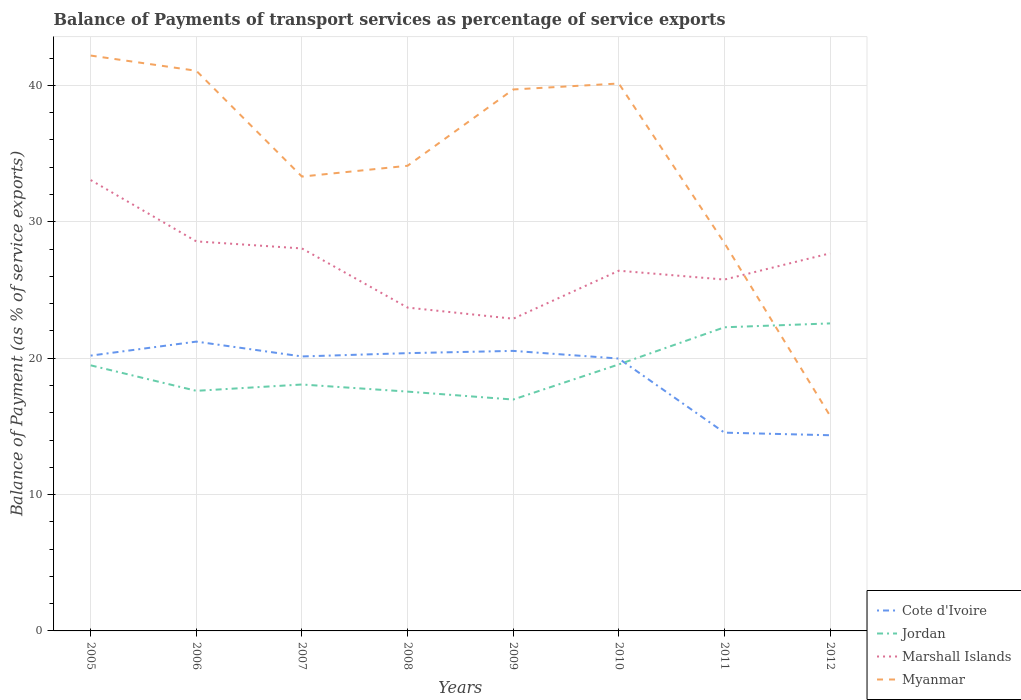How many different coloured lines are there?
Give a very brief answer. 4. Is the number of lines equal to the number of legend labels?
Give a very brief answer. Yes. Across all years, what is the maximum balance of payments of transport services in Marshall Islands?
Your answer should be compact. 22.89. What is the total balance of payments of transport services in Myanmar in the graph?
Your answer should be very brief. 1.12. What is the difference between the highest and the second highest balance of payments of transport services in Cote d'Ivoire?
Your response must be concise. 6.86. What is the difference between the highest and the lowest balance of payments of transport services in Myanmar?
Your answer should be compact. 4. Is the balance of payments of transport services in Jordan strictly greater than the balance of payments of transport services in Myanmar over the years?
Provide a short and direct response. No. How many lines are there?
Provide a succinct answer. 4. Are the values on the major ticks of Y-axis written in scientific E-notation?
Ensure brevity in your answer.  No. Does the graph contain grids?
Give a very brief answer. Yes. How many legend labels are there?
Provide a short and direct response. 4. What is the title of the graph?
Your answer should be compact. Balance of Payments of transport services as percentage of service exports. Does "Hungary" appear as one of the legend labels in the graph?
Make the answer very short. No. What is the label or title of the Y-axis?
Ensure brevity in your answer.  Balance of Payment (as % of service exports). What is the Balance of Payment (as % of service exports) of Cote d'Ivoire in 2005?
Ensure brevity in your answer.  20.19. What is the Balance of Payment (as % of service exports) of Jordan in 2005?
Provide a short and direct response. 19.47. What is the Balance of Payment (as % of service exports) of Marshall Islands in 2005?
Provide a short and direct response. 33.06. What is the Balance of Payment (as % of service exports) in Myanmar in 2005?
Offer a terse response. 42.19. What is the Balance of Payment (as % of service exports) of Cote d'Ivoire in 2006?
Provide a succinct answer. 21.21. What is the Balance of Payment (as % of service exports) in Jordan in 2006?
Provide a succinct answer. 17.61. What is the Balance of Payment (as % of service exports) of Marshall Islands in 2006?
Provide a succinct answer. 28.56. What is the Balance of Payment (as % of service exports) in Myanmar in 2006?
Provide a succinct answer. 41.08. What is the Balance of Payment (as % of service exports) of Cote d'Ivoire in 2007?
Offer a terse response. 20.13. What is the Balance of Payment (as % of service exports) in Jordan in 2007?
Your answer should be compact. 18.07. What is the Balance of Payment (as % of service exports) in Marshall Islands in 2007?
Your answer should be very brief. 28.05. What is the Balance of Payment (as % of service exports) in Myanmar in 2007?
Offer a very short reply. 33.32. What is the Balance of Payment (as % of service exports) of Cote d'Ivoire in 2008?
Provide a succinct answer. 20.37. What is the Balance of Payment (as % of service exports) of Jordan in 2008?
Your response must be concise. 17.55. What is the Balance of Payment (as % of service exports) of Marshall Islands in 2008?
Make the answer very short. 23.71. What is the Balance of Payment (as % of service exports) of Myanmar in 2008?
Your answer should be compact. 34.11. What is the Balance of Payment (as % of service exports) in Cote d'Ivoire in 2009?
Provide a succinct answer. 20.53. What is the Balance of Payment (as % of service exports) of Jordan in 2009?
Keep it short and to the point. 16.97. What is the Balance of Payment (as % of service exports) in Marshall Islands in 2009?
Your answer should be very brief. 22.89. What is the Balance of Payment (as % of service exports) of Myanmar in 2009?
Your answer should be very brief. 39.7. What is the Balance of Payment (as % of service exports) of Cote d'Ivoire in 2010?
Offer a very short reply. 19.97. What is the Balance of Payment (as % of service exports) in Jordan in 2010?
Provide a short and direct response. 19.54. What is the Balance of Payment (as % of service exports) of Marshall Islands in 2010?
Provide a short and direct response. 26.41. What is the Balance of Payment (as % of service exports) of Myanmar in 2010?
Ensure brevity in your answer.  40.14. What is the Balance of Payment (as % of service exports) in Cote d'Ivoire in 2011?
Provide a short and direct response. 14.54. What is the Balance of Payment (as % of service exports) in Jordan in 2011?
Provide a succinct answer. 22.27. What is the Balance of Payment (as % of service exports) in Marshall Islands in 2011?
Provide a short and direct response. 25.76. What is the Balance of Payment (as % of service exports) in Myanmar in 2011?
Your answer should be very brief. 28.44. What is the Balance of Payment (as % of service exports) in Cote d'Ivoire in 2012?
Your answer should be compact. 14.35. What is the Balance of Payment (as % of service exports) in Jordan in 2012?
Offer a very short reply. 22.55. What is the Balance of Payment (as % of service exports) in Marshall Islands in 2012?
Offer a very short reply. 27.69. What is the Balance of Payment (as % of service exports) of Myanmar in 2012?
Provide a short and direct response. 15.77. Across all years, what is the maximum Balance of Payment (as % of service exports) in Cote d'Ivoire?
Provide a short and direct response. 21.21. Across all years, what is the maximum Balance of Payment (as % of service exports) in Jordan?
Provide a short and direct response. 22.55. Across all years, what is the maximum Balance of Payment (as % of service exports) of Marshall Islands?
Your answer should be very brief. 33.06. Across all years, what is the maximum Balance of Payment (as % of service exports) in Myanmar?
Offer a very short reply. 42.19. Across all years, what is the minimum Balance of Payment (as % of service exports) of Cote d'Ivoire?
Your response must be concise. 14.35. Across all years, what is the minimum Balance of Payment (as % of service exports) of Jordan?
Offer a very short reply. 16.97. Across all years, what is the minimum Balance of Payment (as % of service exports) in Marshall Islands?
Ensure brevity in your answer.  22.89. Across all years, what is the minimum Balance of Payment (as % of service exports) of Myanmar?
Keep it short and to the point. 15.77. What is the total Balance of Payment (as % of service exports) of Cote d'Ivoire in the graph?
Offer a very short reply. 151.29. What is the total Balance of Payment (as % of service exports) in Jordan in the graph?
Provide a short and direct response. 154.03. What is the total Balance of Payment (as % of service exports) of Marshall Islands in the graph?
Provide a short and direct response. 216.14. What is the total Balance of Payment (as % of service exports) in Myanmar in the graph?
Your response must be concise. 274.75. What is the difference between the Balance of Payment (as % of service exports) in Cote d'Ivoire in 2005 and that in 2006?
Offer a very short reply. -1.03. What is the difference between the Balance of Payment (as % of service exports) in Jordan in 2005 and that in 2006?
Keep it short and to the point. 1.87. What is the difference between the Balance of Payment (as % of service exports) of Marshall Islands in 2005 and that in 2006?
Your response must be concise. 4.5. What is the difference between the Balance of Payment (as % of service exports) in Myanmar in 2005 and that in 2006?
Your answer should be very brief. 1.12. What is the difference between the Balance of Payment (as % of service exports) in Cote d'Ivoire in 2005 and that in 2007?
Keep it short and to the point. 0.06. What is the difference between the Balance of Payment (as % of service exports) in Jordan in 2005 and that in 2007?
Keep it short and to the point. 1.41. What is the difference between the Balance of Payment (as % of service exports) in Marshall Islands in 2005 and that in 2007?
Make the answer very short. 5.02. What is the difference between the Balance of Payment (as % of service exports) in Myanmar in 2005 and that in 2007?
Ensure brevity in your answer.  8.87. What is the difference between the Balance of Payment (as % of service exports) of Cote d'Ivoire in 2005 and that in 2008?
Provide a succinct answer. -0.18. What is the difference between the Balance of Payment (as % of service exports) in Jordan in 2005 and that in 2008?
Give a very brief answer. 1.93. What is the difference between the Balance of Payment (as % of service exports) of Marshall Islands in 2005 and that in 2008?
Your response must be concise. 9.35. What is the difference between the Balance of Payment (as % of service exports) of Myanmar in 2005 and that in 2008?
Your answer should be compact. 8.08. What is the difference between the Balance of Payment (as % of service exports) of Cote d'Ivoire in 2005 and that in 2009?
Offer a terse response. -0.35. What is the difference between the Balance of Payment (as % of service exports) of Jordan in 2005 and that in 2009?
Your answer should be very brief. 2.51. What is the difference between the Balance of Payment (as % of service exports) of Marshall Islands in 2005 and that in 2009?
Make the answer very short. 10.17. What is the difference between the Balance of Payment (as % of service exports) of Myanmar in 2005 and that in 2009?
Offer a terse response. 2.49. What is the difference between the Balance of Payment (as % of service exports) in Cote d'Ivoire in 2005 and that in 2010?
Offer a very short reply. 0.22. What is the difference between the Balance of Payment (as % of service exports) in Jordan in 2005 and that in 2010?
Offer a terse response. -0.07. What is the difference between the Balance of Payment (as % of service exports) of Marshall Islands in 2005 and that in 2010?
Offer a very short reply. 6.65. What is the difference between the Balance of Payment (as % of service exports) of Myanmar in 2005 and that in 2010?
Your response must be concise. 2.05. What is the difference between the Balance of Payment (as % of service exports) of Cote d'Ivoire in 2005 and that in 2011?
Offer a very short reply. 5.65. What is the difference between the Balance of Payment (as % of service exports) of Jordan in 2005 and that in 2011?
Make the answer very short. -2.79. What is the difference between the Balance of Payment (as % of service exports) in Marshall Islands in 2005 and that in 2011?
Provide a succinct answer. 7.3. What is the difference between the Balance of Payment (as % of service exports) in Myanmar in 2005 and that in 2011?
Your answer should be very brief. 13.75. What is the difference between the Balance of Payment (as % of service exports) of Cote d'Ivoire in 2005 and that in 2012?
Provide a short and direct response. 5.84. What is the difference between the Balance of Payment (as % of service exports) in Jordan in 2005 and that in 2012?
Offer a terse response. -3.07. What is the difference between the Balance of Payment (as % of service exports) in Marshall Islands in 2005 and that in 2012?
Your response must be concise. 5.37. What is the difference between the Balance of Payment (as % of service exports) of Myanmar in 2005 and that in 2012?
Your response must be concise. 26.42. What is the difference between the Balance of Payment (as % of service exports) in Cote d'Ivoire in 2006 and that in 2007?
Your answer should be compact. 1.09. What is the difference between the Balance of Payment (as % of service exports) in Jordan in 2006 and that in 2007?
Give a very brief answer. -0.46. What is the difference between the Balance of Payment (as % of service exports) in Marshall Islands in 2006 and that in 2007?
Ensure brevity in your answer.  0.52. What is the difference between the Balance of Payment (as % of service exports) in Myanmar in 2006 and that in 2007?
Your answer should be compact. 7.76. What is the difference between the Balance of Payment (as % of service exports) of Cote d'Ivoire in 2006 and that in 2008?
Offer a terse response. 0.85. What is the difference between the Balance of Payment (as % of service exports) of Jordan in 2006 and that in 2008?
Make the answer very short. 0.06. What is the difference between the Balance of Payment (as % of service exports) in Marshall Islands in 2006 and that in 2008?
Your answer should be very brief. 4.85. What is the difference between the Balance of Payment (as % of service exports) of Myanmar in 2006 and that in 2008?
Your response must be concise. 6.97. What is the difference between the Balance of Payment (as % of service exports) in Cote d'Ivoire in 2006 and that in 2009?
Provide a short and direct response. 0.68. What is the difference between the Balance of Payment (as % of service exports) of Jordan in 2006 and that in 2009?
Your answer should be very brief. 0.64. What is the difference between the Balance of Payment (as % of service exports) of Marshall Islands in 2006 and that in 2009?
Keep it short and to the point. 5.67. What is the difference between the Balance of Payment (as % of service exports) of Myanmar in 2006 and that in 2009?
Provide a succinct answer. 1.37. What is the difference between the Balance of Payment (as % of service exports) of Cote d'Ivoire in 2006 and that in 2010?
Provide a succinct answer. 1.24. What is the difference between the Balance of Payment (as % of service exports) of Jordan in 2006 and that in 2010?
Offer a terse response. -1.94. What is the difference between the Balance of Payment (as % of service exports) of Marshall Islands in 2006 and that in 2010?
Keep it short and to the point. 2.15. What is the difference between the Balance of Payment (as % of service exports) in Myanmar in 2006 and that in 2010?
Provide a succinct answer. 0.93. What is the difference between the Balance of Payment (as % of service exports) in Cote d'Ivoire in 2006 and that in 2011?
Offer a very short reply. 6.68. What is the difference between the Balance of Payment (as % of service exports) in Jordan in 2006 and that in 2011?
Keep it short and to the point. -4.66. What is the difference between the Balance of Payment (as % of service exports) in Marshall Islands in 2006 and that in 2011?
Provide a succinct answer. 2.8. What is the difference between the Balance of Payment (as % of service exports) in Myanmar in 2006 and that in 2011?
Keep it short and to the point. 12.63. What is the difference between the Balance of Payment (as % of service exports) of Cote d'Ivoire in 2006 and that in 2012?
Provide a succinct answer. 6.87. What is the difference between the Balance of Payment (as % of service exports) of Jordan in 2006 and that in 2012?
Ensure brevity in your answer.  -4.94. What is the difference between the Balance of Payment (as % of service exports) of Marshall Islands in 2006 and that in 2012?
Offer a very short reply. 0.88. What is the difference between the Balance of Payment (as % of service exports) of Myanmar in 2006 and that in 2012?
Your answer should be very brief. 25.3. What is the difference between the Balance of Payment (as % of service exports) in Cote d'Ivoire in 2007 and that in 2008?
Ensure brevity in your answer.  -0.24. What is the difference between the Balance of Payment (as % of service exports) of Jordan in 2007 and that in 2008?
Make the answer very short. 0.52. What is the difference between the Balance of Payment (as % of service exports) of Marshall Islands in 2007 and that in 2008?
Offer a very short reply. 4.34. What is the difference between the Balance of Payment (as % of service exports) of Myanmar in 2007 and that in 2008?
Give a very brief answer. -0.79. What is the difference between the Balance of Payment (as % of service exports) in Cote d'Ivoire in 2007 and that in 2009?
Provide a short and direct response. -0.41. What is the difference between the Balance of Payment (as % of service exports) of Jordan in 2007 and that in 2009?
Keep it short and to the point. 1.1. What is the difference between the Balance of Payment (as % of service exports) in Marshall Islands in 2007 and that in 2009?
Provide a short and direct response. 5.15. What is the difference between the Balance of Payment (as % of service exports) of Myanmar in 2007 and that in 2009?
Your answer should be very brief. -6.39. What is the difference between the Balance of Payment (as % of service exports) in Cote d'Ivoire in 2007 and that in 2010?
Provide a short and direct response. 0.15. What is the difference between the Balance of Payment (as % of service exports) of Jordan in 2007 and that in 2010?
Your answer should be compact. -1.47. What is the difference between the Balance of Payment (as % of service exports) in Marshall Islands in 2007 and that in 2010?
Your answer should be compact. 1.63. What is the difference between the Balance of Payment (as % of service exports) of Myanmar in 2007 and that in 2010?
Your answer should be very brief. -6.82. What is the difference between the Balance of Payment (as % of service exports) of Cote d'Ivoire in 2007 and that in 2011?
Ensure brevity in your answer.  5.59. What is the difference between the Balance of Payment (as % of service exports) in Jordan in 2007 and that in 2011?
Offer a very short reply. -4.2. What is the difference between the Balance of Payment (as % of service exports) of Marshall Islands in 2007 and that in 2011?
Provide a short and direct response. 2.28. What is the difference between the Balance of Payment (as % of service exports) in Myanmar in 2007 and that in 2011?
Ensure brevity in your answer.  4.87. What is the difference between the Balance of Payment (as % of service exports) in Cote d'Ivoire in 2007 and that in 2012?
Your answer should be very brief. 5.78. What is the difference between the Balance of Payment (as % of service exports) of Jordan in 2007 and that in 2012?
Offer a very short reply. -4.48. What is the difference between the Balance of Payment (as % of service exports) of Marshall Islands in 2007 and that in 2012?
Offer a terse response. 0.36. What is the difference between the Balance of Payment (as % of service exports) of Myanmar in 2007 and that in 2012?
Your answer should be compact. 17.54. What is the difference between the Balance of Payment (as % of service exports) in Cote d'Ivoire in 2008 and that in 2009?
Offer a terse response. -0.17. What is the difference between the Balance of Payment (as % of service exports) of Jordan in 2008 and that in 2009?
Make the answer very short. 0.58. What is the difference between the Balance of Payment (as % of service exports) of Marshall Islands in 2008 and that in 2009?
Offer a very short reply. 0.82. What is the difference between the Balance of Payment (as % of service exports) in Myanmar in 2008 and that in 2009?
Keep it short and to the point. -5.59. What is the difference between the Balance of Payment (as % of service exports) of Cote d'Ivoire in 2008 and that in 2010?
Offer a terse response. 0.4. What is the difference between the Balance of Payment (as % of service exports) in Jordan in 2008 and that in 2010?
Ensure brevity in your answer.  -1.99. What is the difference between the Balance of Payment (as % of service exports) of Marshall Islands in 2008 and that in 2010?
Your response must be concise. -2.7. What is the difference between the Balance of Payment (as % of service exports) in Myanmar in 2008 and that in 2010?
Make the answer very short. -6.03. What is the difference between the Balance of Payment (as % of service exports) in Cote d'Ivoire in 2008 and that in 2011?
Your answer should be very brief. 5.83. What is the difference between the Balance of Payment (as % of service exports) of Jordan in 2008 and that in 2011?
Keep it short and to the point. -4.72. What is the difference between the Balance of Payment (as % of service exports) of Marshall Islands in 2008 and that in 2011?
Provide a short and direct response. -2.05. What is the difference between the Balance of Payment (as % of service exports) of Myanmar in 2008 and that in 2011?
Give a very brief answer. 5.67. What is the difference between the Balance of Payment (as % of service exports) of Cote d'Ivoire in 2008 and that in 2012?
Your answer should be compact. 6.02. What is the difference between the Balance of Payment (as % of service exports) of Jordan in 2008 and that in 2012?
Offer a terse response. -5. What is the difference between the Balance of Payment (as % of service exports) of Marshall Islands in 2008 and that in 2012?
Your answer should be compact. -3.98. What is the difference between the Balance of Payment (as % of service exports) in Myanmar in 2008 and that in 2012?
Provide a succinct answer. 18.34. What is the difference between the Balance of Payment (as % of service exports) in Cote d'Ivoire in 2009 and that in 2010?
Your answer should be compact. 0.56. What is the difference between the Balance of Payment (as % of service exports) of Jordan in 2009 and that in 2010?
Give a very brief answer. -2.58. What is the difference between the Balance of Payment (as % of service exports) of Marshall Islands in 2009 and that in 2010?
Give a very brief answer. -3.52. What is the difference between the Balance of Payment (as % of service exports) in Myanmar in 2009 and that in 2010?
Give a very brief answer. -0.44. What is the difference between the Balance of Payment (as % of service exports) of Cote d'Ivoire in 2009 and that in 2011?
Offer a terse response. 6. What is the difference between the Balance of Payment (as % of service exports) in Jordan in 2009 and that in 2011?
Give a very brief answer. -5.3. What is the difference between the Balance of Payment (as % of service exports) in Marshall Islands in 2009 and that in 2011?
Ensure brevity in your answer.  -2.87. What is the difference between the Balance of Payment (as % of service exports) of Myanmar in 2009 and that in 2011?
Offer a very short reply. 11.26. What is the difference between the Balance of Payment (as % of service exports) in Cote d'Ivoire in 2009 and that in 2012?
Provide a succinct answer. 6.18. What is the difference between the Balance of Payment (as % of service exports) of Jordan in 2009 and that in 2012?
Your response must be concise. -5.58. What is the difference between the Balance of Payment (as % of service exports) of Marshall Islands in 2009 and that in 2012?
Give a very brief answer. -4.8. What is the difference between the Balance of Payment (as % of service exports) in Myanmar in 2009 and that in 2012?
Offer a terse response. 23.93. What is the difference between the Balance of Payment (as % of service exports) of Cote d'Ivoire in 2010 and that in 2011?
Provide a succinct answer. 5.43. What is the difference between the Balance of Payment (as % of service exports) of Jordan in 2010 and that in 2011?
Keep it short and to the point. -2.72. What is the difference between the Balance of Payment (as % of service exports) of Marshall Islands in 2010 and that in 2011?
Provide a short and direct response. 0.65. What is the difference between the Balance of Payment (as % of service exports) of Myanmar in 2010 and that in 2011?
Ensure brevity in your answer.  11.7. What is the difference between the Balance of Payment (as % of service exports) in Cote d'Ivoire in 2010 and that in 2012?
Your answer should be compact. 5.62. What is the difference between the Balance of Payment (as % of service exports) of Jordan in 2010 and that in 2012?
Ensure brevity in your answer.  -3.01. What is the difference between the Balance of Payment (as % of service exports) of Marshall Islands in 2010 and that in 2012?
Offer a very short reply. -1.27. What is the difference between the Balance of Payment (as % of service exports) in Myanmar in 2010 and that in 2012?
Your response must be concise. 24.37. What is the difference between the Balance of Payment (as % of service exports) in Cote d'Ivoire in 2011 and that in 2012?
Give a very brief answer. 0.19. What is the difference between the Balance of Payment (as % of service exports) in Jordan in 2011 and that in 2012?
Your answer should be compact. -0.28. What is the difference between the Balance of Payment (as % of service exports) of Marshall Islands in 2011 and that in 2012?
Give a very brief answer. -1.92. What is the difference between the Balance of Payment (as % of service exports) of Myanmar in 2011 and that in 2012?
Your answer should be very brief. 12.67. What is the difference between the Balance of Payment (as % of service exports) of Cote d'Ivoire in 2005 and the Balance of Payment (as % of service exports) of Jordan in 2006?
Keep it short and to the point. 2.58. What is the difference between the Balance of Payment (as % of service exports) of Cote d'Ivoire in 2005 and the Balance of Payment (as % of service exports) of Marshall Islands in 2006?
Your response must be concise. -8.38. What is the difference between the Balance of Payment (as % of service exports) in Cote d'Ivoire in 2005 and the Balance of Payment (as % of service exports) in Myanmar in 2006?
Offer a very short reply. -20.89. What is the difference between the Balance of Payment (as % of service exports) in Jordan in 2005 and the Balance of Payment (as % of service exports) in Marshall Islands in 2006?
Provide a succinct answer. -9.09. What is the difference between the Balance of Payment (as % of service exports) of Jordan in 2005 and the Balance of Payment (as % of service exports) of Myanmar in 2006?
Your response must be concise. -21.6. What is the difference between the Balance of Payment (as % of service exports) of Marshall Islands in 2005 and the Balance of Payment (as % of service exports) of Myanmar in 2006?
Provide a succinct answer. -8.01. What is the difference between the Balance of Payment (as % of service exports) of Cote d'Ivoire in 2005 and the Balance of Payment (as % of service exports) of Jordan in 2007?
Ensure brevity in your answer.  2.12. What is the difference between the Balance of Payment (as % of service exports) of Cote d'Ivoire in 2005 and the Balance of Payment (as % of service exports) of Marshall Islands in 2007?
Offer a very short reply. -7.86. What is the difference between the Balance of Payment (as % of service exports) of Cote d'Ivoire in 2005 and the Balance of Payment (as % of service exports) of Myanmar in 2007?
Your answer should be very brief. -13.13. What is the difference between the Balance of Payment (as % of service exports) of Jordan in 2005 and the Balance of Payment (as % of service exports) of Marshall Islands in 2007?
Your response must be concise. -8.57. What is the difference between the Balance of Payment (as % of service exports) of Jordan in 2005 and the Balance of Payment (as % of service exports) of Myanmar in 2007?
Offer a terse response. -13.84. What is the difference between the Balance of Payment (as % of service exports) in Marshall Islands in 2005 and the Balance of Payment (as % of service exports) in Myanmar in 2007?
Provide a succinct answer. -0.26. What is the difference between the Balance of Payment (as % of service exports) in Cote d'Ivoire in 2005 and the Balance of Payment (as % of service exports) in Jordan in 2008?
Give a very brief answer. 2.64. What is the difference between the Balance of Payment (as % of service exports) of Cote d'Ivoire in 2005 and the Balance of Payment (as % of service exports) of Marshall Islands in 2008?
Your response must be concise. -3.52. What is the difference between the Balance of Payment (as % of service exports) in Cote d'Ivoire in 2005 and the Balance of Payment (as % of service exports) in Myanmar in 2008?
Offer a terse response. -13.92. What is the difference between the Balance of Payment (as % of service exports) of Jordan in 2005 and the Balance of Payment (as % of service exports) of Marshall Islands in 2008?
Offer a very short reply. -4.24. What is the difference between the Balance of Payment (as % of service exports) in Jordan in 2005 and the Balance of Payment (as % of service exports) in Myanmar in 2008?
Provide a succinct answer. -14.63. What is the difference between the Balance of Payment (as % of service exports) of Marshall Islands in 2005 and the Balance of Payment (as % of service exports) of Myanmar in 2008?
Your answer should be compact. -1.05. What is the difference between the Balance of Payment (as % of service exports) of Cote d'Ivoire in 2005 and the Balance of Payment (as % of service exports) of Jordan in 2009?
Your answer should be compact. 3.22. What is the difference between the Balance of Payment (as % of service exports) in Cote d'Ivoire in 2005 and the Balance of Payment (as % of service exports) in Marshall Islands in 2009?
Offer a very short reply. -2.7. What is the difference between the Balance of Payment (as % of service exports) in Cote d'Ivoire in 2005 and the Balance of Payment (as % of service exports) in Myanmar in 2009?
Give a very brief answer. -19.52. What is the difference between the Balance of Payment (as % of service exports) of Jordan in 2005 and the Balance of Payment (as % of service exports) of Marshall Islands in 2009?
Keep it short and to the point. -3.42. What is the difference between the Balance of Payment (as % of service exports) in Jordan in 2005 and the Balance of Payment (as % of service exports) in Myanmar in 2009?
Make the answer very short. -20.23. What is the difference between the Balance of Payment (as % of service exports) of Marshall Islands in 2005 and the Balance of Payment (as % of service exports) of Myanmar in 2009?
Keep it short and to the point. -6.64. What is the difference between the Balance of Payment (as % of service exports) of Cote d'Ivoire in 2005 and the Balance of Payment (as % of service exports) of Jordan in 2010?
Ensure brevity in your answer.  0.64. What is the difference between the Balance of Payment (as % of service exports) of Cote d'Ivoire in 2005 and the Balance of Payment (as % of service exports) of Marshall Islands in 2010?
Your answer should be very brief. -6.23. What is the difference between the Balance of Payment (as % of service exports) in Cote d'Ivoire in 2005 and the Balance of Payment (as % of service exports) in Myanmar in 2010?
Ensure brevity in your answer.  -19.95. What is the difference between the Balance of Payment (as % of service exports) of Jordan in 2005 and the Balance of Payment (as % of service exports) of Marshall Islands in 2010?
Offer a very short reply. -6.94. What is the difference between the Balance of Payment (as % of service exports) of Jordan in 2005 and the Balance of Payment (as % of service exports) of Myanmar in 2010?
Provide a succinct answer. -20.67. What is the difference between the Balance of Payment (as % of service exports) in Marshall Islands in 2005 and the Balance of Payment (as % of service exports) in Myanmar in 2010?
Your answer should be very brief. -7.08. What is the difference between the Balance of Payment (as % of service exports) of Cote d'Ivoire in 2005 and the Balance of Payment (as % of service exports) of Jordan in 2011?
Give a very brief answer. -2.08. What is the difference between the Balance of Payment (as % of service exports) in Cote d'Ivoire in 2005 and the Balance of Payment (as % of service exports) in Marshall Islands in 2011?
Ensure brevity in your answer.  -5.58. What is the difference between the Balance of Payment (as % of service exports) in Cote d'Ivoire in 2005 and the Balance of Payment (as % of service exports) in Myanmar in 2011?
Provide a short and direct response. -8.26. What is the difference between the Balance of Payment (as % of service exports) in Jordan in 2005 and the Balance of Payment (as % of service exports) in Marshall Islands in 2011?
Make the answer very short. -6.29. What is the difference between the Balance of Payment (as % of service exports) in Jordan in 2005 and the Balance of Payment (as % of service exports) in Myanmar in 2011?
Your answer should be compact. -8.97. What is the difference between the Balance of Payment (as % of service exports) of Marshall Islands in 2005 and the Balance of Payment (as % of service exports) of Myanmar in 2011?
Offer a terse response. 4.62. What is the difference between the Balance of Payment (as % of service exports) of Cote d'Ivoire in 2005 and the Balance of Payment (as % of service exports) of Jordan in 2012?
Ensure brevity in your answer.  -2.36. What is the difference between the Balance of Payment (as % of service exports) of Cote d'Ivoire in 2005 and the Balance of Payment (as % of service exports) of Marshall Islands in 2012?
Make the answer very short. -7.5. What is the difference between the Balance of Payment (as % of service exports) in Cote d'Ivoire in 2005 and the Balance of Payment (as % of service exports) in Myanmar in 2012?
Keep it short and to the point. 4.41. What is the difference between the Balance of Payment (as % of service exports) in Jordan in 2005 and the Balance of Payment (as % of service exports) in Marshall Islands in 2012?
Give a very brief answer. -8.21. What is the difference between the Balance of Payment (as % of service exports) of Jordan in 2005 and the Balance of Payment (as % of service exports) of Myanmar in 2012?
Give a very brief answer. 3.7. What is the difference between the Balance of Payment (as % of service exports) in Marshall Islands in 2005 and the Balance of Payment (as % of service exports) in Myanmar in 2012?
Keep it short and to the point. 17.29. What is the difference between the Balance of Payment (as % of service exports) in Cote d'Ivoire in 2006 and the Balance of Payment (as % of service exports) in Jordan in 2007?
Make the answer very short. 3.15. What is the difference between the Balance of Payment (as % of service exports) of Cote d'Ivoire in 2006 and the Balance of Payment (as % of service exports) of Marshall Islands in 2007?
Ensure brevity in your answer.  -6.83. What is the difference between the Balance of Payment (as % of service exports) of Cote d'Ivoire in 2006 and the Balance of Payment (as % of service exports) of Myanmar in 2007?
Ensure brevity in your answer.  -12.1. What is the difference between the Balance of Payment (as % of service exports) in Jordan in 2006 and the Balance of Payment (as % of service exports) in Marshall Islands in 2007?
Offer a very short reply. -10.44. What is the difference between the Balance of Payment (as % of service exports) in Jordan in 2006 and the Balance of Payment (as % of service exports) in Myanmar in 2007?
Your answer should be very brief. -15.71. What is the difference between the Balance of Payment (as % of service exports) of Marshall Islands in 2006 and the Balance of Payment (as % of service exports) of Myanmar in 2007?
Make the answer very short. -4.75. What is the difference between the Balance of Payment (as % of service exports) of Cote d'Ivoire in 2006 and the Balance of Payment (as % of service exports) of Jordan in 2008?
Ensure brevity in your answer.  3.67. What is the difference between the Balance of Payment (as % of service exports) of Cote d'Ivoire in 2006 and the Balance of Payment (as % of service exports) of Marshall Islands in 2008?
Offer a terse response. -2.5. What is the difference between the Balance of Payment (as % of service exports) of Cote d'Ivoire in 2006 and the Balance of Payment (as % of service exports) of Myanmar in 2008?
Offer a very short reply. -12.89. What is the difference between the Balance of Payment (as % of service exports) in Jordan in 2006 and the Balance of Payment (as % of service exports) in Marshall Islands in 2008?
Make the answer very short. -6.1. What is the difference between the Balance of Payment (as % of service exports) of Jordan in 2006 and the Balance of Payment (as % of service exports) of Myanmar in 2008?
Ensure brevity in your answer.  -16.5. What is the difference between the Balance of Payment (as % of service exports) in Marshall Islands in 2006 and the Balance of Payment (as % of service exports) in Myanmar in 2008?
Offer a terse response. -5.54. What is the difference between the Balance of Payment (as % of service exports) in Cote d'Ivoire in 2006 and the Balance of Payment (as % of service exports) in Jordan in 2009?
Give a very brief answer. 4.25. What is the difference between the Balance of Payment (as % of service exports) in Cote d'Ivoire in 2006 and the Balance of Payment (as % of service exports) in Marshall Islands in 2009?
Provide a succinct answer. -1.68. What is the difference between the Balance of Payment (as % of service exports) of Cote d'Ivoire in 2006 and the Balance of Payment (as % of service exports) of Myanmar in 2009?
Your answer should be compact. -18.49. What is the difference between the Balance of Payment (as % of service exports) of Jordan in 2006 and the Balance of Payment (as % of service exports) of Marshall Islands in 2009?
Offer a terse response. -5.29. What is the difference between the Balance of Payment (as % of service exports) in Jordan in 2006 and the Balance of Payment (as % of service exports) in Myanmar in 2009?
Ensure brevity in your answer.  -22.1. What is the difference between the Balance of Payment (as % of service exports) of Marshall Islands in 2006 and the Balance of Payment (as % of service exports) of Myanmar in 2009?
Ensure brevity in your answer.  -11.14. What is the difference between the Balance of Payment (as % of service exports) of Cote d'Ivoire in 2006 and the Balance of Payment (as % of service exports) of Jordan in 2010?
Your answer should be very brief. 1.67. What is the difference between the Balance of Payment (as % of service exports) in Cote d'Ivoire in 2006 and the Balance of Payment (as % of service exports) in Marshall Islands in 2010?
Your response must be concise. -5.2. What is the difference between the Balance of Payment (as % of service exports) of Cote d'Ivoire in 2006 and the Balance of Payment (as % of service exports) of Myanmar in 2010?
Your answer should be compact. -18.93. What is the difference between the Balance of Payment (as % of service exports) in Jordan in 2006 and the Balance of Payment (as % of service exports) in Marshall Islands in 2010?
Give a very brief answer. -8.81. What is the difference between the Balance of Payment (as % of service exports) in Jordan in 2006 and the Balance of Payment (as % of service exports) in Myanmar in 2010?
Make the answer very short. -22.54. What is the difference between the Balance of Payment (as % of service exports) of Marshall Islands in 2006 and the Balance of Payment (as % of service exports) of Myanmar in 2010?
Offer a very short reply. -11.58. What is the difference between the Balance of Payment (as % of service exports) of Cote d'Ivoire in 2006 and the Balance of Payment (as % of service exports) of Jordan in 2011?
Offer a terse response. -1.05. What is the difference between the Balance of Payment (as % of service exports) in Cote d'Ivoire in 2006 and the Balance of Payment (as % of service exports) in Marshall Islands in 2011?
Give a very brief answer. -4.55. What is the difference between the Balance of Payment (as % of service exports) of Cote d'Ivoire in 2006 and the Balance of Payment (as % of service exports) of Myanmar in 2011?
Ensure brevity in your answer.  -7.23. What is the difference between the Balance of Payment (as % of service exports) in Jordan in 2006 and the Balance of Payment (as % of service exports) in Marshall Islands in 2011?
Offer a terse response. -8.16. What is the difference between the Balance of Payment (as % of service exports) in Jordan in 2006 and the Balance of Payment (as % of service exports) in Myanmar in 2011?
Your answer should be very brief. -10.84. What is the difference between the Balance of Payment (as % of service exports) in Marshall Islands in 2006 and the Balance of Payment (as % of service exports) in Myanmar in 2011?
Offer a very short reply. 0.12. What is the difference between the Balance of Payment (as % of service exports) in Cote d'Ivoire in 2006 and the Balance of Payment (as % of service exports) in Jordan in 2012?
Offer a terse response. -1.33. What is the difference between the Balance of Payment (as % of service exports) in Cote d'Ivoire in 2006 and the Balance of Payment (as % of service exports) in Marshall Islands in 2012?
Provide a succinct answer. -6.47. What is the difference between the Balance of Payment (as % of service exports) of Cote d'Ivoire in 2006 and the Balance of Payment (as % of service exports) of Myanmar in 2012?
Your answer should be very brief. 5.44. What is the difference between the Balance of Payment (as % of service exports) in Jordan in 2006 and the Balance of Payment (as % of service exports) in Marshall Islands in 2012?
Offer a very short reply. -10.08. What is the difference between the Balance of Payment (as % of service exports) in Jordan in 2006 and the Balance of Payment (as % of service exports) in Myanmar in 2012?
Your answer should be compact. 1.83. What is the difference between the Balance of Payment (as % of service exports) in Marshall Islands in 2006 and the Balance of Payment (as % of service exports) in Myanmar in 2012?
Provide a succinct answer. 12.79. What is the difference between the Balance of Payment (as % of service exports) of Cote d'Ivoire in 2007 and the Balance of Payment (as % of service exports) of Jordan in 2008?
Provide a succinct answer. 2.58. What is the difference between the Balance of Payment (as % of service exports) in Cote d'Ivoire in 2007 and the Balance of Payment (as % of service exports) in Marshall Islands in 2008?
Give a very brief answer. -3.58. What is the difference between the Balance of Payment (as % of service exports) of Cote d'Ivoire in 2007 and the Balance of Payment (as % of service exports) of Myanmar in 2008?
Your answer should be compact. -13.98. What is the difference between the Balance of Payment (as % of service exports) of Jordan in 2007 and the Balance of Payment (as % of service exports) of Marshall Islands in 2008?
Your answer should be very brief. -5.64. What is the difference between the Balance of Payment (as % of service exports) in Jordan in 2007 and the Balance of Payment (as % of service exports) in Myanmar in 2008?
Make the answer very short. -16.04. What is the difference between the Balance of Payment (as % of service exports) in Marshall Islands in 2007 and the Balance of Payment (as % of service exports) in Myanmar in 2008?
Your answer should be compact. -6.06. What is the difference between the Balance of Payment (as % of service exports) in Cote d'Ivoire in 2007 and the Balance of Payment (as % of service exports) in Jordan in 2009?
Provide a succinct answer. 3.16. What is the difference between the Balance of Payment (as % of service exports) in Cote d'Ivoire in 2007 and the Balance of Payment (as % of service exports) in Marshall Islands in 2009?
Give a very brief answer. -2.77. What is the difference between the Balance of Payment (as % of service exports) of Cote d'Ivoire in 2007 and the Balance of Payment (as % of service exports) of Myanmar in 2009?
Ensure brevity in your answer.  -19.58. What is the difference between the Balance of Payment (as % of service exports) of Jordan in 2007 and the Balance of Payment (as % of service exports) of Marshall Islands in 2009?
Offer a very short reply. -4.82. What is the difference between the Balance of Payment (as % of service exports) of Jordan in 2007 and the Balance of Payment (as % of service exports) of Myanmar in 2009?
Give a very brief answer. -21.63. What is the difference between the Balance of Payment (as % of service exports) in Marshall Islands in 2007 and the Balance of Payment (as % of service exports) in Myanmar in 2009?
Offer a very short reply. -11.66. What is the difference between the Balance of Payment (as % of service exports) in Cote d'Ivoire in 2007 and the Balance of Payment (as % of service exports) in Jordan in 2010?
Offer a terse response. 0.58. What is the difference between the Balance of Payment (as % of service exports) of Cote d'Ivoire in 2007 and the Balance of Payment (as % of service exports) of Marshall Islands in 2010?
Offer a very short reply. -6.29. What is the difference between the Balance of Payment (as % of service exports) in Cote d'Ivoire in 2007 and the Balance of Payment (as % of service exports) in Myanmar in 2010?
Give a very brief answer. -20.01. What is the difference between the Balance of Payment (as % of service exports) in Jordan in 2007 and the Balance of Payment (as % of service exports) in Marshall Islands in 2010?
Your answer should be very brief. -8.34. What is the difference between the Balance of Payment (as % of service exports) of Jordan in 2007 and the Balance of Payment (as % of service exports) of Myanmar in 2010?
Provide a succinct answer. -22.07. What is the difference between the Balance of Payment (as % of service exports) of Marshall Islands in 2007 and the Balance of Payment (as % of service exports) of Myanmar in 2010?
Offer a very short reply. -12.1. What is the difference between the Balance of Payment (as % of service exports) in Cote d'Ivoire in 2007 and the Balance of Payment (as % of service exports) in Jordan in 2011?
Make the answer very short. -2.14. What is the difference between the Balance of Payment (as % of service exports) in Cote d'Ivoire in 2007 and the Balance of Payment (as % of service exports) in Marshall Islands in 2011?
Give a very brief answer. -5.64. What is the difference between the Balance of Payment (as % of service exports) in Cote d'Ivoire in 2007 and the Balance of Payment (as % of service exports) in Myanmar in 2011?
Keep it short and to the point. -8.32. What is the difference between the Balance of Payment (as % of service exports) of Jordan in 2007 and the Balance of Payment (as % of service exports) of Marshall Islands in 2011?
Ensure brevity in your answer.  -7.69. What is the difference between the Balance of Payment (as % of service exports) of Jordan in 2007 and the Balance of Payment (as % of service exports) of Myanmar in 2011?
Your answer should be very brief. -10.37. What is the difference between the Balance of Payment (as % of service exports) in Marshall Islands in 2007 and the Balance of Payment (as % of service exports) in Myanmar in 2011?
Your answer should be compact. -0.4. What is the difference between the Balance of Payment (as % of service exports) of Cote d'Ivoire in 2007 and the Balance of Payment (as % of service exports) of Jordan in 2012?
Your response must be concise. -2.42. What is the difference between the Balance of Payment (as % of service exports) in Cote d'Ivoire in 2007 and the Balance of Payment (as % of service exports) in Marshall Islands in 2012?
Provide a short and direct response. -7.56. What is the difference between the Balance of Payment (as % of service exports) in Cote d'Ivoire in 2007 and the Balance of Payment (as % of service exports) in Myanmar in 2012?
Ensure brevity in your answer.  4.35. What is the difference between the Balance of Payment (as % of service exports) in Jordan in 2007 and the Balance of Payment (as % of service exports) in Marshall Islands in 2012?
Ensure brevity in your answer.  -9.62. What is the difference between the Balance of Payment (as % of service exports) of Jordan in 2007 and the Balance of Payment (as % of service exports) of Myanmar in 2012?
Your answer should be very brief. 2.3. What is the difference between the Balance of Payment (as % of service exports) of Marshall Islands in 2007 and the Balance of Payment (as % of service exports) of Myanmar in 2012?
Your response must be concise. 12.27. What is the difference between the Balance of Payment (as % of service exports) in Cote d'Ivoire in 2008 and the Balance of Payment (as % of service exports) in Jordan in 2009?
Ensure brevity in your answer.  3.4. What is the difference between the Balance of Payment (as % of service exports) in Cote d'Ivoire in 2008 and the Balance of Payment (as % of service exports) in Marshall Islands in 2009?
Your answer should be compact. -2.52. What is the difference between the Balance of Payment (as % of service exports) in Cote d'Ivoire in 2008 and the Balance of Payment (as % of service exports) in Myanmar in 2009?
Your answer should be compact. -19.34. What is the difference between the Balance of Payment (as % of service exports) of Jordan in 2008 and the Balance of Payment (as % of service exports) of Marshall Islands in 2009?
Offer a very short reply. -5.34. What is the difference between the Balance of Payment (as % of service exports) of Jordan in 2008 and the Balance of Payment (as % of service exports) of Myanmar in 2009?
Offer a terse response. -22.16. What is the difference between the Balance of Payment (as % of service exports) in Marshall Islands in 2008 and the Balance of Payment (as % of service exports) in Myanmar in 2009?
Ensure brevity in your answer.  -15.99. What is the difference between the Balance of Payment (as % of service exports) in Cote d'Ivoire in 2008 and the Balance of Payment (as % of service exports) in Jordan in 2010?
Offer a very short reply. 0.82. What is the difference between the Balance of Payment (as % of service exports) in Cote d'Ivoire in 2008 and the Balance of Payment (as % of service exports) in Marshall Islands in 2010?
Provide a short and direct response. -6.05. What is the difference between the Balance of Payment (as % of service exports) of Cote d'Ivoire in 2008 and the Balance of Payment (as % of service exports) of Myanmar in 2010?
Provide a succinct answer. -19.77. What is the difference between the Balance of Payment (as % of service exports) of Jordan in 2008 and the Balance of Payment (as % of service exports) of Marshall Islands in 2010?
Give a very brief answer. -8.87. What is the difference between the Balance of Payment (as % of service exports) in Jordan in 2008 and the Balance of Payment (as % of service exports) in Myanmar in 2010?
Make the answer very short. -22.59. What is the difference between the Balance of Payment (as % of service exports) in Marshall Islands in 2008 and the Balance of Payment (as % of service exports) in Myanmar in 2010?
Ensure brevity in your answer.  -16.43. What is the difference between the Balance of Payment (as % of service exports) of Cote d'Ivoire in 2008 and the Balance of Payment (as % of service exports) of Jordan in 2011?
Ensure brevity in your answer.  -1.9. What is the difference between the Balance of Payment (as % of service exports) of Cote d'Ivoire in 2008 and the Balance of Payment (as % of service exports) of Marshall Islands in 2011?
Ensure brevity in your answer.  -5.4. What is the difference between the Balance of Payment (as % of service exports) in Cote d'Ivoire in 2008 and the Balance of Payment (as % of service exports) in Myanmar in 2011?
Keep it short and to the point. -8.07. What is the difference between the Balance of Payment (as % of service exports) of Jordan in 2008 and the Balance of Payment (as % of service exports) of Marshall Islands in 2011?
Keep it short and to the point. -8.22. What is the difference between the Balance of Payment (as % of service exports) in Jordan in 2008 and the Balance of Payment (as % of service exports) in Myanmar in 2011?
Your answer should be compact. -10.89. What is the difference between the Balance of Payment (as % of service exports) of Marshall Islands in 2008 and the Balance of Payment (as % of service exports) of Myanmar in 2011?
Your answer should be very brief. -4.73. What is the difference between the Balance of Payment (as % of service exports) in Cote d'Ivoire in 2008 and the Balance of Payment (as % of service exports) in Jordan in 2012?
Give a very brief answer. -2.18. What is the difference between the Balance of Payment (as % of service exports) of Cote d'Ivoire in 2008 and the Balance of Payment (as % of service exports) of Marshall Islands in 2012?
Offer a very short reply. -7.32. What is the difference between the Balance of Payment (as % of service exports) of Cote d'Ivoire in 2008 and the Balance of Payment (as % of service exports) of Myanmar in 2012?
Provide a short and direct response. 4.6. What is the difference between the Balance of Payment (as % of service exports) of Jordan in 2008 and the Balance of Payment (as % of service exports) of Marshall Islands in 2012?
Ensure brevity in your answer.  -10.14. What is the difference between the Balance of Payment (as % of service exports) in Jordan in 2008 and the Balance of Payment (as % of service exports) in Myanmar in 2012?
Offer a terse response. 1.78. What is the difference between the Balance of Payment (as % of service exports) in Marshall Islands in 2008 and the Balance of Payment (as % of service exports) in Myanmar in 2012?
Provide a succinct answer. 7.94. What is the difference between the Balance of Payment (as % of service exports) in Cote d'Ivoire in 2009 and the Balance of Payment (as % of service exports) in Jordan in 2010?
Give a very brief answer. 0.99. What is the difference between the Balance of Payment (as % of service exports) of Cote d'Ivoire in 2009 and the Balance of Payment (as % of service exports) of Marshall Islands in 2010?
Make the answer very short. -5.88. What is the difference between the Balance of Payment (as % of service exports) in Cote d'Ivoire in 2009 and the Balance of Payment (as % of service exports) in Myanmar in 2010?
Keep it short and to the point. -19.61. What is the difference between the Balance of Payment (as % of service exports) in Jordan in 2009 and the Balance of Payment (as % of service exports) in Marshall Islands in 2010?
Offer a terse response. -9.45. What is the difference between the Balance of Payment (as % of service exports) in Jordan in 2009 and the Balance of Payment (as % of service exports) in Myanmar in 2010?
Ensure brevity in your answer.  -23.17. What is the difference between the Balance of Payment (as % of service exports) in Marshall Islands in 2009 and the Balance of Payment (as % of service exports) in Myanmar in 2010?
Give a very brief answer. -17.25. What is the difference between the Balance of Payment (as % of service exports) of Cote d'Ivoire in 2009 and the Balance of Payment (as % of service exports) of Jordan in 2011?
Make the answer very short. -1.73. What is the difference between the Balance of Payment (as % of service exports) of Cote d'Ivoire in 2009 and the Balance of Payment (as % of service exports) of Marshall Islands in 2011?
Your answer should be very brief. -5.23. What is the difference between the Balance of Payment (as % of service exports) of Cote d'Ivoire in 2009 and the Balance of Payment (as % of service exports) of Myanmar in 2011?
Ensure brevity in your answer.  -7.91. What is the difference between the Balance of Payment (as % of service exports) of Jordan in 2009 and the Balance of Payment (as % of service exports) of Marshall Islands in 2011?
Your answer should be compact. -8.8. What is the difference between the Balance of Payment (as % of service exports) of Jordan in 2009 and the Balance of Payment (as % of service exports) of Myanmar in 2011?
Offer a terse response. -11.48. What is the difference between the Balance of Payment (as % of service exports) of Marshall Islands in 2009 and the Balance of Payment (as % of service exports) of Myanmar in 2011?
Offer a very short reply. -5.55. What is the difference between the Balance of Payment (as % of service exports) in Cote d'Ivoire in 2009 and the Balance of Payment (as % of service exports) in Jordan in 2012?
Make the answer very short. -2.02. What is the difference between the Balance of Payment (as % of service exports) of Cote d'Ivoire in 2009 and the Balance of Payment (as % of service exports) of Marshall Islands in 2012?
Keep it short and to the point. -7.15. What is the difference between the Balance of Payment (as % of service exports) in Cote d'Ivoire in 2009 and the Balance of Payment (as % of service exports) in Myanmar in 2012?
Provide a short and direct response. 4.76. What is the difference between the Balance of Payment (as % of service exports) of Jordan in 2009 and the Balance of Payment (as % of service exports) of Marshall Islands in 2012?
Your response must be concise. -10.72. What is the difference between the Balance of Payment (as % of service exports) of Jordan in 2009 and the Balance of Payment (as % of service exports) of Myanmar in 2012?
Provide a short and direct response. 1.19. What is the difference between the Balance of Payment (as % of service exports) in Marshall Islands in 2009 and the Balance of Payment (as % of service exports) in Myanmar in 2012?
Make the answer very short. 7.12. What is the difference between the Balance of Payment (as % of service exports) in Cote d'Ivoire in 2010 and the Balance of Payment (as % of service exports) in Jordan in 2011?
Your answer should be very brief. -2.29. What is the difference between the Balance of Payment (as % of service exports) of Cote d'Ivoire in 2010 and the Balance of Payment (as % of service exports) of Marshall Islands in 2011?
Give a very brief answer. -5.79. What is the difference between the Balance of Payment (as % of service exports) in Cote d'Ivoire in 2010 and the Balance of Payment (as % of service exports) in Myanmar in 2011?
Provide a short and direct response. -8.47. What is the difference between the Balance of Payment (as % of service exports) of Jordan in 2010 and the Balance of Payment (as % of service exports) of Marshall Islands in 2011?
Offer a terse response. -6.22. What is the difference between the Balance of Payment (as % of service exports) in Jordan in 2010 and the Balance of Payment (as % of service exports) in Myanmar in 2011?
Your answer should be compact. -8.9. What is the difference between the Balance of Payment (as % of service exports) of Marshall Islands in 2010 and the Balance of Payment (as % of service exports) of Myanmar in 2011?
Keep it short and to the point. -2.03. What is the difference between the Balance of Payment (as % of service exports) in Cote d'Ivoire in 2010 and the Balance of Payment (as % of service exports) in Jordan in 2012?
Your answer should be very brief. -2.58. What is the difference between the Balance of Payment (as % of service exports) of Cote d'Ivoire in 2010 and the Balance of Payment (as % of service exports) of Marshall Islands in 2012?
Provide a succinct answer. -7.72. What is the difference between the Balance of Payment (as % of service exports) of Cote d'Ivoire in 2010 and the Balance of Payment (as % of service exports) of Myanmar in 2012?
Provide a short and direct response. 4.2. What is the difference between the Balance of Payment (as % of service exports) in Jordan in 2010 and the Balance of Payment (as % of service exports) in Marshall Islands in 2012?
Keep it short and to the point. -8.14. What is the difference between the Balance of Payment (as % of service exports) in Jordan in 2010 and the Balance of Payment (as % of service exports) in Myanmar in 2012?
Your answer should be compact. 3.77. What is the difference between the Balance of Payment (as % of service exports) of Marshall Islands in 2010 and the Balance of Payment (as % of service exports) of Myanmar in 2012?
Your answer should be very brief. 10.64. What is the difference between the Balance of Payment (as % of service exports) in Cote d'Ivoire in 2011 and the Balance of Payment (as % of service exports) in Jordan in 2012?
Ensure brevity in your answer.  -8.01. What is the difference between the Balance of Payment (as % of service exports) in Cote d'Ivoire in 2011 and the Balance of Payment (as % of service exports) in Marshall Islands in 2012?
Keep it short and to the point. -13.15. What is the difference between the Balance of Payment (as % of service exports) in Cote d'Ivoire in 2011 and the Balance of Payment (as % of service exports) in Myanmar in 2012?
Your answer should be very brief. -1.24. What is the difference between the Balance of Payment (as % of service exports) in Jordan in 2011 and the Balance of Payment (as % of service exports) in Marshall Islands in 2012?
Make the answer very short. -5.42. What is the difference between the Balance of Payment (as % of service exports) of Jordan in 2011 and the Balance of Payment (as % of service exports) of Myanmar in 2012?
Your answer should be very brief. 6.49. What is the difference between the Balance of Payment (as % of service exports) of Marshall Islands in 2011 and the Balance of Payment (as % of service exports) of Myanmar in 2012?
Give a very brief answer. 9.99. What is the average Balance of Payment (as % of service exports) in Cote d'Ivoire per year?
Provide a succinct answer. 18.91. What is the average Balance of Payment (as % of service exports) in Jordan per year?
Ensure brevity in your answer.  19.25. What is the average Balance of Payment (as % of service exports) of Marshall Islands per year?
Your answer should be very brief. 27.02. What is the average Balance of Payment (as % of service exports) in Myanmar per year?
Your answer should be compact. 34.34. In the year 2005, what is the difference between the Balance of Payment (as % of service exports) in Cote d'Ivoire and Balance of Payment (as % of service exports) in Jordan?
Provide a succinct answer. 0.71. In the year 2005, what is the difference between the Balance of Payment (as % of service exports) in Cote d'Ivoire and Balance of Payment (as % of service exports) in Marshall Islands?
Ensure brevity in your answer.  -12.87. In the year 2005, what is the difference between the Balance of Payment (as % of service exports) of Cote d'Ivoire and Balance of Payment (as % of service exports) of Myanmar?
Give a very brief answer. -22. In the year 2005, what is the difference between the Balance of Payment (as % of service exports) of Jordan and Balance of Payment (as % of service exports) of Marshall Islands?
Ensure brevity in your answer.  -13.59. In the year 2005, what is the difference between the Balance of Payment (as % of service exports) in Jordan and Balance of Payment (as % of service exports) in Myanmar?
Your response must be concise. -22.72. In the year 2005, what is the difference between the Balance of Payment (as % of service exports) in Marshall Islands and Balance of Payment (as % of service exports) in Myanmar?
Keep it short and to the point. -9.13. In the year 2006, what is the difference between the Balance of Payment (as % of service exports) in Cote d'Ivoire and Balance of Payment (as % of service exports) in Jordan?
Provide a succinct answer. 3.61. In the year 2006, what is the difference between the Balance of Payment (as % of service exports) of Cote d'Ivoire and Balance of Payment (as % of service exports) of Marshall Islands?
Give a very brief answer. -7.35. In the year 2006, what is the difference between the Balance of Payment (as % of service exports) in Cote d'Ivoire and Balance of Payment (as % of service exports) in Myanmar?
Keep it short and to the point. -19.86. In the year 2006, what is the difference between the Balance of Payment (as % of service exports) in Jordan and Balance of Payment (as % of service exports) in Marshall Islands?
Keep it short and to the point. -10.96. In the year 2006, what is the difference between the Balance of Payment (as % of service exports) in Jordan and Balance of Payment (as % of service exports) in Myanmar?
Make the answer very short. -23.47. In the year 2006, what is the difference between the Balance of Payment (as % of service exports) of Marshall Islands and Balance of Payment (as % of service exports) of Myanmar?
Make the answer very short. -12.51. In the year 2007, what is the difference between the Balance of Payment (as % of service exports) in Cote d'Ivoire and Balance of Payment (as % of service exports) in Jordan?
Provide a succinct answer. 2.06. In the year 2007, what is the difference between the Balance of Payment (as % of service exports) of Cote d'Ivoire and Balance of Payment (as % of service exports) of Marshall Islands?
Keep it short and to the point. -7.92. In the year 2007, what is the difference between the Balance of Payment (as % of service exports) of Cote d'Ivoire and Balance of Payment (as % of service exports) of Myanmar?
Give a very brief answer. -13.19. In the year 2007, what is the difference between the Balance of Payment (as % of service exports) of Jordan and Balance of Payment (as % of service exports) of Marshall Islands?
Make the answer very short. -9.98. In the year 2007, what is the difference between the Balance of Payment (as % of service exports) in Jordan and Balance of Payment (as % of service exports) in Myanmar?
Provide a succinct answer. -15.25. In the year 2007, what is the difference between the Balance of Payment (as % of service exports) in Marshall Islands and Balance of Payment (as % of service exports) in Myanmar?
Provide a succinct answer. -5.27. In the year 2008, what is the difference between the Balance of Payment (as % of service exports) of Cote d'Ivoire and Balance of Payment (as % of service exports) of Jordan?
Provide a succinct answer. 2.82. In the year 2008, what is the difference between the Balance of Payment (as % of service exports) of Cote d'Ivoire and Balance of Payment (as % of service exports) of Marshall Islands?
Your answer should be compact. -3.34. In the year 2008, what is the difference between the Balance of Payment (as % of service exports) of Cote d'Ivoire and Balance of Payment (as % of service exports) of Myanmar?
Your answer should be compact. -13.74. In the year 2008, what is the difference between the Balance of Payment (as % of service exports) in Jordan and Balance of Payment (as % of service exports) in Marshall Islands?
Offer a terse response. -6.16. In the year 2008, what is the difference between the Balance of Payment (as % of service exports) of Jordan and Balance of Payment (as % of service exports) of Myanmar?
Offer a terse response. -16.56. In the year 2008, what is the difference between the Balance of Payment (as % of service exports) in Marshall Islands and Balance of Payment (as % of service exports) in Myanmar?
Your answer should be very brief. -10.4. In the year 2009, what is the difference between the Balance of Payment (as % of service exports) in Cote d'Ivoire and Balance of Payment (as % of service exports) in Jordan?
Make the answer very short. 3.57. In the year 2009, what is the difference between the Balance of Payment (as % of service exports) in Cote d'Ivoire and Balance of Payment (as % of service exports) in Marshall Islands?
Your answer should be very brief. -2.36. In the year 2009, what is the difference between the Balance of Payment (as % of service exports) of Cote d'Ivoire and Balance of Payment (as % of service exports) of Myanmar?
Keep it short and to the point. -19.17. In the year 2009, what is the difference between the Balance of Payment (as % of service exports) in Jordan and Balance of Payment (as % of service exports) in Marshall Islands?
Your answer should be very brief. -5.93. In the year 2009, what is the difference between the Balance of Payment (as % of service exports) in Jordan and Balance of Payment (as % of service exports) in Myanmar?
Give a very brief answer. -22.74. In the year 2009, what is the difference between the Balance of Payment (as % of service exports) of Marshall Islands and Balance of Payment (as % of service exports) of Myanmar?
Give a very brief answer. -16.81. In the year 2010, what is the difference between the Balance of Payment (as % of service exports) in Cote d'Ivoire and Balance of Payment (as % of service exports) in Jordan?
Give a very brief answer. 0.43. In the year 2010, what is the difference between the Balance of Payment (as % of service exports) in Cote d'Ivoire and Balance of Payment (as % of service exports) in Marshall Islands?
Ensure brevity in your answer.  -6.44. In the year 2010, what is the difference between the Balance of Payment (as % of service exports) of Cote d'Ivoire and Balance of Payment (as % of service exports) of Myanmar?
Your response must be concise. -20.17. In the year 2010, what is the difference between the Balance of Payment (as % of service exports) in Jordan and Balance of Payment (as % of service exports) in Marshall Islands?
Provide a succinct answer. -6.87. In the year 2010, what is the difference between the Balance of Payment (as % of service exports) of Jordan and Balance of Payment (as % of service exports) of Myanmar?
Make the answer very short. -20.6. In the year 2010, what is the difference between the Balance of Payment (as % of service exports) in Marshall Islands and Balance of Payment (as % of service exports) in Myanmar?
Provide a short and direct response. -13.73. In the year 2011, what is the difference between the Balance of Payment (as % of service exports) of Cote d'Ivoire and Balance of Payment (as % of service exports) of Jordan?
Make the answer very short. -7.73. In the year 2011, what is the difference between the Balance of Payment (as % of service exports) in Cote d'Ivoire and Balance of Payment (as % of service exports) in Marshall Islands?
Offer a very short reply. -11.23. In the year 2011, what is the difference between the Balance of Payment (as % of service exports) in Cote d'Ivoire and Balance of Payment (as % of service exports) in Myanmar?
Your answer should be very brief. -13.91. In the year 2011, what is the difference between the Balance of Payment (as % of service exports) in Jordan and Balance of Payment (as % of service exports) in Marshall Islands?
Offer a terse response. -3.5. In the year 2011, what is the difference between the Balance of Payment (as % of service exports) of Jordan and Balance of Payment (as % of service exports) of Myanmar?
Offer a very short reply. -6.18. In the year 2011, what is the difference between the Balance of Payment (as % of service exports) of Marshall Islands and Balance of Payment (as % of service exports) of Myanmar?
Provide a short and direct response. -2.68. In the year 2012, what is the difference between the Balance of Payment (as % of service exports) of Cote d'Ivoire and Balance of Payment (as % of service exports) of Jordan?
Give a very brief answer. -8.2. In the year 2012, what is the difference between the Balance of Payment (as % of service exports) in Cote d'Ivoire and Balance of Payment (as % of service exports) in Marshall Islands?
Give a very brief answer. -13.34. In the year 2012, what is the difference between the Balance of Payment (as % of service exports) in Cote d'Ivoire and Balance of Payment (as % of service exports) in Myanmar?
Ensure brevity in your answer.  -1.42. In the year 2012, what is the difference between the Balance of Payment (as % of service exports) in Jordan and Balance of Payment (as % of service exports) in Marshall Islands?
Your answer should be very brief. -5.14. In the year 2012, what is the difference between the Balance of Payment (as % of service exports) in Jordan and Balance of Payment (as % of service exports) in Myanmar?
Your answer should be compact. 6.78. In the year 2012, what is the difference between the Balance of Payment (as % of service exports) in Marshall Islands and Balance of Payment (as % of service exports) in Myanmar?
Provide a short and direct response. 11.92. What is the ratio of the Balance of Payment (as % of service exports) of Cote d'Ivoire in 2005 to that in 2006?
Make the answer very short. 0.95. What is the ratio of the Balance of Payment (as % of service exports) of Jordan in 2005 to that in 2006?
Offer a very short reply. 1.11. What is the ratio of the Balance of Payment (as % of service exports) of Marshall Islands in 2005 to that in 2006?
Offer a terse response. 1.16. What is the ratio of the Balance of Payment (as % of service exports) of Myanmar in 2005 to that in 2006?
Ensure brevity in your answer.  1.03. What is the ratio of the Balance of Payment (as % of service exports) in Jordan in 2005 to that in 2007?
Your answer should be very brief. 1.08. What is the ratio of the Balance of Payment (as % of service exports) in Marshall Islands in 2005 to that in 2007?
Your response must be concise. 1.18. What is the ratio of the Balance of Payment (as % of service exports) in Myanmar in 2005 to that in 2007?
Your answer should be very brief. 1.27. What is the ratio of the Balance of Payment (as % of service exports) in Jordan in 2005 to that in 2008?
Keep it short and to the point. 1.11. What is the ratio of the Balance of Payment (as % of service exports) in Marshall Islands in 2005 to that in 2008?
Offer a terse response. 1.39. What is the ratio of the Balance of Payment (as % of service exports) of Myanmar in 2005 to that in 2008?
Keep it short and to the point. 1.24. What is the ratio of the Balance of Payment (as % of service exports) of Cote d'Ivoire in 2005 to that in 2009?
Your answer should be compact. 0.98. What is the ratio of the Balance of Payment (as % of service exports) in Jordan in 2005 to that in 2009?
Ensure brevity in your answer.  1.15. What is the ratio of the Balance of Payment (as % of service exports) in Marshall Islands in 2005 to that in 2009?
Your answer should be very brief. 1.44. What is the ratio of the Balance of Payment (as % of service exports) in Myanmar in 2005 to that in 2009?
Your answer should be compact. 1.06. What is the ratio of the Balance of Payment (as % of service exports) in Cote d'Ivoire in 2005 to that in 2010?
Provide a succinct answer. 1.01. What is the ratio of the Balance of Payment (as % of service exports) of Jordan in 2005 to that in 2010?
Provide a succinct answer. 1. What is the ratio of the Balance of Payment (as % of service exports) in Marshall Islands in 2005 to that in 2010?
Ensure brevity in your answer.  1.25. What is the ratio of the Balance of Payment (as % of service exports) of Myanmar in 2005 to that in 2010?
Offer a terse response. 1.05. What is the ratio of the Balance of Payment (as % of service exports) of Cote d'Ivoire in 2005 to that in 2011?
Provide a short and direct response. 1.39. What is the ratio of the Balance of Payment (as % of service exports) in Jordan in 2005 to that in 2011?
Your answer should be compact. 0.87. What is the ratio of the Balance of Payment (as % of service exports) of Marshall Islands in 2005 to that in 2011?
Ensure brevity in your answer.  1.28. What is the ratio of the Balance of Payment (as % of service exports) in Myanmar in 2005 to that in 2011?
Your answer should be compact. 1.48. What is the ratio of the Balance of Payment (as % of service exports) of Cote d'Ivoire in 2005 to that in 2012?
Ensure brevity in your answer.  1.41. What is the ratio of the Balance of Payment (as % of service exports) in Jordan in 2005 to that in 2012?
Your response must be concise. 0.86. What is the ratio of the Balance of Payment (as % of service exports) of Marshall Islands in 2005 to that in 2012?
Offer a very short reply. 1.19. What is the ratio of the Balance of Payment (as % of service exports) of Myanmar in 2005 to that in 2012?
Your answer should be very brief. 2.67. What is the ratio of the Balance of Payment (as % of service exports) in Cote d'Ivoire in 2006 to that in 2007?
Your answer should be compact. 1.05. What is the ratio of the Balance of Payment (as % of service exports) in Jordan in 2006 to that in 2007?
Your answer should be compact. 0.97. What is the ratio of the Balance of Payment (as % of service exports) in Marshall Islands in 2006 to that in 2007?
Give a very brief answer. 1.02. What is the ratio of the Balance of Payment (as % of service exports) in Myanmar in 2006 to that in 2007?
Your answer should be compact. 1.23. What is the ratio of the Balance of Payment (as % of service exports) of Cote d'Ivoire in 2006 to that in 2008?
Provide a short and direct response. 1.04. What is the ratio of the Balance of Payment (as % of service exports) of Marshall Islands in 2006 to that in 2008?
Ensure brevity in your answer.  1.2. What is the ratio of the Balance of Payment (as % of service exports) of Myanmar in 2006 to that in 2008?
Keep it short and to the point. 1.2. What is the ratio of the Balance of Payment (as % of service exports) of Cote d'Ivoire in 2006 to that in 2009?
Provide a succinct answer. 1.03. What is the ratio of the Balance of Payment (as % of service exports) of Jordan in 2006 to that in 2009?
Your answer should be compact. 1.04. What is the ratio of the Balance of Payment (as % of service exports) in Marshall Islands in 2006 to that in 2009?
Offer a terse response. 1.25. What is the ratio of the Balance of Payment (as % of service exports) in Myanmar in 2006 to that in 2009?
Your response must be concise. 1.03. What is the ratio of the Balance of Payment (as % of service exports) in Cote d'Ivoire in 2006 to that in 2010?
Offer a terse response. 1.06. What is the ratio of the Balance of Payment (as % of service exports) in Jordan in 2006 to that in 2010?
Offer a very short reply. 0.9. What is the ratio of the Balance of Payment (as % of service exports) in Marshall Islands in 2006 to that in 2010?
Your response must be concise. 1.08. What is the ratio of the Balance of Payment (as % of service exports) of Myanmar in 2006 to that in 2010?
Your answer should be very brief. 1.02. What is the ratio of the Balance of Payment (as % of service exports) in Cote d'Ivoire in 2006 to that in 2011?
Offer a very short reply. 1.46. What is the ratio of the Balance of Payment (as % of service exports) in Jordan in 2006 to that in 2011?
Give a very brief answer. 0.79. What is the ratio of the Balance of Payment (as % of service exports) in Marshall Islands in 2006 to that in 2011?
Your response must be concise. 1.11. What is the ratio of the Balance of Payment (as % of service exports) of Myanmar in 2006 to that in 2011?
Keep it short and to the point. 1.44. What is the ratio of the Balance of Payment (as % of service exports) of Cote d'Ivoire in 2006 to that in 2012?
Make the answer very short. 1.48. What is the ratio of the Balance of Payment (as % of service exports) of Jordan in 2006 to that in 2012?
Offer a terse response. 0.78. What is the ratio of the Balance of Payment (as % of service exports) of Marshall Islands in 2006 to that in 2012?
Your answer should be very brief. 1.03. What is the ratio of the Balance of Payment (as % of service exports) in Myanmar in 2006 to that in 2012?
Ensure brevity in your answer.  2.6. What is the ratio of the Balance of Payment (as % of service exports) of Cote d'Ivoire in 2007 to that in 2008?
Ensure brevity in your answer.  0.99. What is the ratio of the Balance of Payment (as % of service exports) in Jordan in 2007 to that in 2008?
Offer a terse response. 1.03. What is the ratio of the Balance of Payment (as % of service exports) of Marshall Islands in 2007 to that in 2008?
Make the answer very short. 1.18. What is the ratio of the Balance of Payment (as % of service exports) in Myanmar in 2007 to that in 2008?
Offer a terse response. 0.98. What is the ratio of the Balance of Payment (as % of service exports) of Cote d'Ivoire in 2007 to that in 2009?
Give a very brief answer. 0.98. What is the ratio of the Balance of Payment (as % of service exports) in Jordan in 2007 to that in 2009?
Provide a succinct answer. 1.06. What is the ratio of the Balance of Payment (as % of service exports) in Marshall Islands in 2007 to that in 2009?
Your response must be concise. 1.23. What is the ratio of the Balance of Payment (as % of service exports) of Myanmar in 2007 to that in 2009?
Keep it short and to the point. 0.84. What is the ratio of the Balance of Payment (as % of service exports) of Cote d'Ivoire in 2007 to that in 2010?
Offer a terse response. 1.01. What is the ratio of the Balance of Payment (as % of service exports) in Jordan in 2007 to that in 2010?
Offer a terse response. 0.92. What is the ratio of the Balance of Payment (as % of service exports) in Marshall Islands in 2007 to that in 2010?
Offer a very short reply. 1.06. What is the ratio of the Balance of Payment (as % of service exports) in Myanmar in 2007 to that in 2010?
Offer a very short reply. 0.83. What is the ratio of the Balance of Payment (as % of service exports) of Cote d'Ivoire in 2007 to that in 2011?
Provide a succinct answer. 1.38. What is the ratio of the Balance of Payment (as % of service exports) in Jordan in 2007 to that in 2011?
Your answer should be very brief. 0.81. What is the ratio of the Balance of Payment (as % of service exports) in Marshall Islands in 2007 to that in 2011?
Offer a very short reply. 1.09. What is the ratio of the Balance of Payment (as % of service exports) of Myanmar in 2007 to that in 2011?
Offer a very short reply. 1.17. What is the ratio of the Balance of Payment (as % of service exports) in Cote d'Ivoire in 2007 to that in 2012?
Keep it short and to the point. 1.4. What is the ratio of the Balance of Payment (as % of service exports) in Jordan in 2007 to that in 2012?
Offer a very short reply. 0.8. What is the ratio of the Balance of Payment (as % of service exports) of Marshall Islands in 2007 to that in 2012?
Provide a succinct answer. 1.01. What is the ratio of the Balance of Payment (as % of service exports) in Myanmar in 2007 to that in 2012?
Give a very brief answer. 2.11. What is the ratio of the Balance of Payment (as % of service exports) in Jordan in 2008 to that in 2009?
Your answer should be very brief. 1.03. What is the ratio of the Balance of Payment (as % of service exports) in Marshall Islands in 2008 to that in 2009?
Give a very brief answer. 1.04. What is the ratio of the Balance of Payment (as % of service exports) of Myanmar in 2008 to that in 2009?
Offer a very short reply. 0.86. What is the ratio of the Balance of Payment (as % of service exports) of Cote d'Ivoire in 2008 to that in 2010?
Your answer should be compact. 1.02. What is the ratio of the Balance of Payment (as % of service exports) of Jordan in 2008 to that in 2010?
Offer a very short reply. 0.9. What is the ratio of the Balance of Payment (as % of service exports) of Marshall Islands in 2008 to that in 2010?
Offer a terse response. 0.9. What is the ratio of the Balance of Payment (as % of service exports) of Myanmar in 2008 to that in 2010?
Provide a short and direct response. 0.85. What is the ratio of the Balance of Payment (as % of service exports) of Cote d'Ivoire in 2008 to that in 2011?
Provide a short and direct response. 1.4. What is the ratio of the Balance of Payment (as % of service exports) in Jordan in 2008 to that in 2011?
Give a very brief answer. 0.79. What is the ratio of the Balance of Payment (as % of service exports) in Marshall Islands in 2008 to that in 2011?
Provide a succinct answer. 0.92. What is the ratio of the Balance of Payment (as % of service exports) in Myanmar in 2008 to that in 2011?
Offer a terse response. 1.2. What is the ratio of the Balance of Payment (as % of service exports) of Cote d'Ivoire in 2008 to that in 2012?
Make the answer very short. 1.42. What is the ratio of the Balance of Payment (as % of service exports) in Jordan in 2008 to that in 2012?
Make the answer very short. 0.78. What is the ratio of the Balance of Payment (as % of service exports) of Marshall Islands in 2008 to that in 2012?
Provide a short and direct response. 0.86. What is the ratio of the Balance of Payment (as % of service exports) in Myanmar in 2008 to that in 2012?
Ensure brevity in your answer.  2.16. What is the ratio of the Balance of Payment (as % of service exports) of Cote d'Ivoire in 2009 to that in 2010?
Offer a terse response. 1.03. What is the ratio of the Balance of Payment (as % of service exports) of Jordan in 2009 to that in 2010?
Your answer should be very brief. 0.87. What is the ratio of the Balance of Payment (as % of service exports) in Marshall Islands in 2009 to that in 2010?
Your answer should be compact. 0.87. What is the ratio of the Balance of Payment (as % of service exports) in Myanmar in 2009 to that in 2010?
Your answer should be very brief. 0.99. What is the ratio of the Balance of Payment (as % of service exports) of Cote d'Ivoire in 2009 to that in 2011?
Make the answer very short. 1.41. What is the ratio of the Balance of Payment (as % of service exports) in Jordan in 2009 to that in 2011?
Provide a succinct answer. 0.76. What is the ratio of the Balance of Payment (as % of service exports) in Marshall Islands in 2009 to that in 2011?
Your response must be concise. 0.89. What is the ratio of the Balance of Payment (as % of service exports) in Myanmar in 2009 to that in 2011?
Ensure brevity in your answer.  1.4. What is the ratio of the Balance of Payment (as % of service exports) of Cote d'Ivoire in 2009 to that in 2012?
Offer a terse response. 1.43. What is the ratio of the Balance of Payment (as % of service exports) of Jordan in 2009 to that in 2012?
Provide a short and direct response. 0.75. What is the ratio of the Balance of Payment (as % of service exports) of Marshall Islands in 2009 to that in 2012?
Ensure brevity in your answer.  0.83. What is the ratio of the Balance of Payment (as % of service exports) of Myanmar in 2009 to that in 2012?
Your response must be concise. 2.52. What is the ratio of the Balance of Payment (as % of service exports) of Cote d'Ivoire in 2010 to that in 2011?
Provide a short and direct response. 1.37. What is the ratio of the Balance of Payment (as % of service exports) in Jordan in 2010 to that in 2011?
Give a very brief answer. 0.88. What is the ratio of the Balance of Payment (as % of service exports) in Marshall Islands in 2010 to that in 2011?
Offer a very short reply. 1.03. What is the ratio of the Balance of Payment (as % of service exports) of Myanmar in 2010 to that in 2011?
Your answer should be compact. 1.41. What is the ratio of the Balance of Payment (as % of service exports) in Cote d'Ivoire in 2010 to that in 2012?
Provide a succinct answer. 1.39. What is the ratio of the Balance of Payment (as % of service exports) of Jordan in 2010 to that in 2012?
Offer a terse response. 0.87. What is the ratio of the Balance of Payment (as % of service exports) of Marshall Islands in 2010 to that in 2012?
Keep it short and to the point. 0.95. What is the ratio of the Balance of Payment (as % of service exports) in Myanmar in 2010 to that in 2012?
Provide a short and direct response. 2.54. What is the ratio of the Balance of Payment (as % of service exports) in Cote d'Ivoire in 2011 to that in 2012?
Offer a very short reply. 1.01. What is the ratio of the Balance of Payment (as % of service exports) of Jordan in 2011 to that in 2012?
Provide a short and direct response. 0.99. What is the ratio of the Balance of Payment (as % of service exports) of Marshall Islands in 2011 to that in 2012?
Provide a succinct answer. 0.93. What is the ratio of the Balance of Payment (as % of service exports) in Myanmar in 2011 to that in 2012?
Your answer should be compact. 1.8. What is the difference between the highest and the second highest Balance of Payment (as % of service exports) of Cote d'Ivoire?
Offer a very short reply. 0.68. What is the difference between the highest and the second highest Balance of Payment (as % of service exports) in Jordan?
Offer a terse response. 0.28. What is the difference between the highest and the second highest Balance of Payment (as % of service exports) of Marshall Islands?
Offer a very short reply. 4.5. What is the difference between the highest and the second highest Balance of Payment (as % of service exports) in Myanmar?
Provide a short and direct response. 1.12. What is the difference between the highest and the lowest Balance of Payment (as % of service exports) in Cote d'Ivoire?
Your answer should be compact. 6.87. What is the difference between the highest and the lowest Balance of Payment (as % of service exports) in Jordan?
Provide a short and direct response. 5.58. What is the difference between the highest and the lowest Balance of Payment (as % of service exports) in Marshall Islands?
Offer a terse response. 10.17. What is the difference between the highest and the lowest Balance of Payment (as % of service exports) of Myanmar?
Provide a succinct answer. 26.42. 